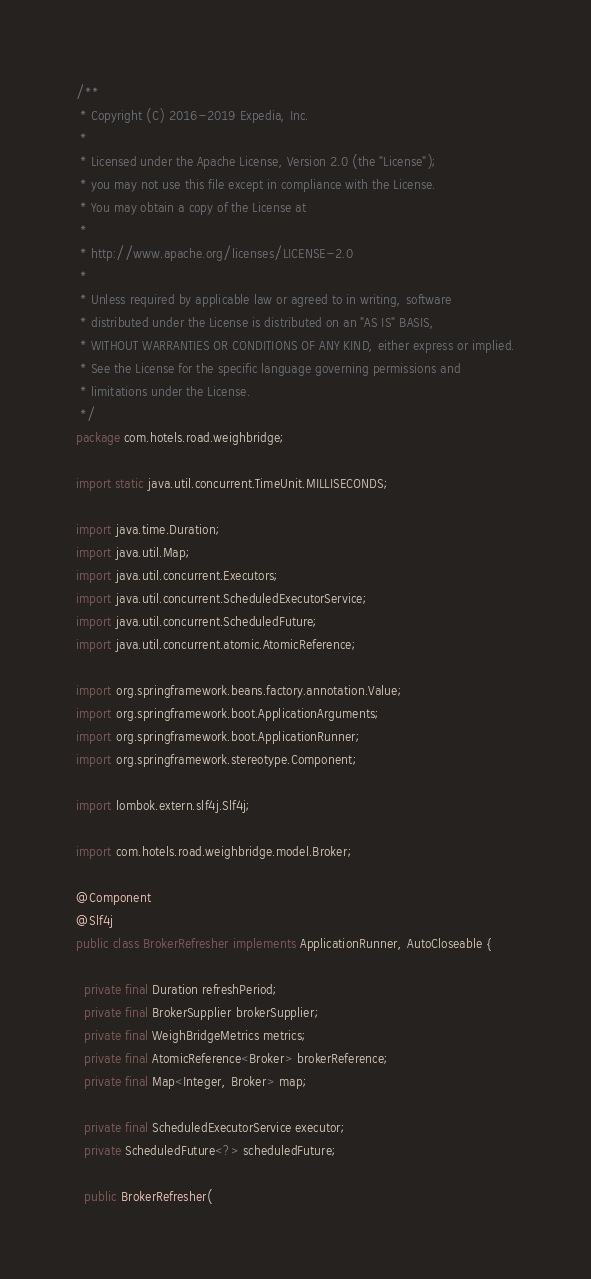<code> <loc_0><loc_0><loc_500><loc_500><_Java_>/**
 * Copyright (C) 2016-2019 Expedia, Inc.
 *
 * Licensed under the Apache License, Version 2.0 (the "License");
 * you may not use this file except in compliance with the License.
 * You may obtain a copy of the License at
 *
 * http://www.apache.org/licenses/LICENSE-2.0
 *
 * Unless required by applicable law or agreed to in writing, software
 * distributed under the License is distributed on an "AS IS" BASIS,
 * WITHOUT WARRANTIES OR CONDITIONS OF ANY KIND, either express or implied.
 * See the License for the specific language governing permissions and
 * limitations under the License.
 */
package com.hotels.road.weighbridge;

import static java.util.concurrent.TimeUnit.MILLISECONDS;

import java.time.Duration;
import java.util.Map;
import java.util.concurrent.Executors;
import java.util.concurrent.ScheduledExecutorService;
import java.util.concurrent.ScheduledFuture;
import java.util.concurrent.atomic.AtomicReference;

import org.springframework.beans.factory.annotation.Value;
import org.springframework.boot.ApplicationArguments;
import org.springframework.boot.ApplicationRunner;
import org.springframework.stereotype.Component;

import lombok.extern.slf4j.Slf4j;

import com.hotels.road.weighbridge.model.Broker;

@Component
@Slf4j
public class BrokerRefresher implements ApplicationRunner, AutoCloseable {

  private final Duration refreshPeriod;
  private final BrokerSupplier brokerSupplier;
  private final WeighBridgeMetrics metrics;
  private final AtomicReference<Broker> brokerReference;
  private final Map<Integer, Broker> map;

  private final ScheduledExecutorService executor;
  private ScheduledFuture<?> scheduledFuture;

  public BrokerRefresher(</code> 